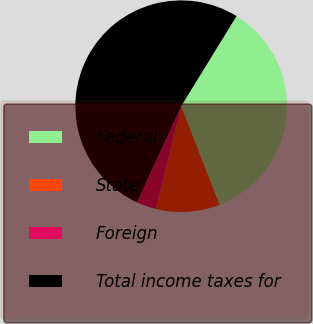Convert chart to OTSL. <chart><loc_0><loc_0><loc_500><loc_500><pie_chart><fcel>Federal<fcel>State<fcel>Foreign<fcel>Total income taxes for<nl><fcel>35.32%<fcel>9.72%<fcel>3.04%<fcel>51.93%<nl></chart> 